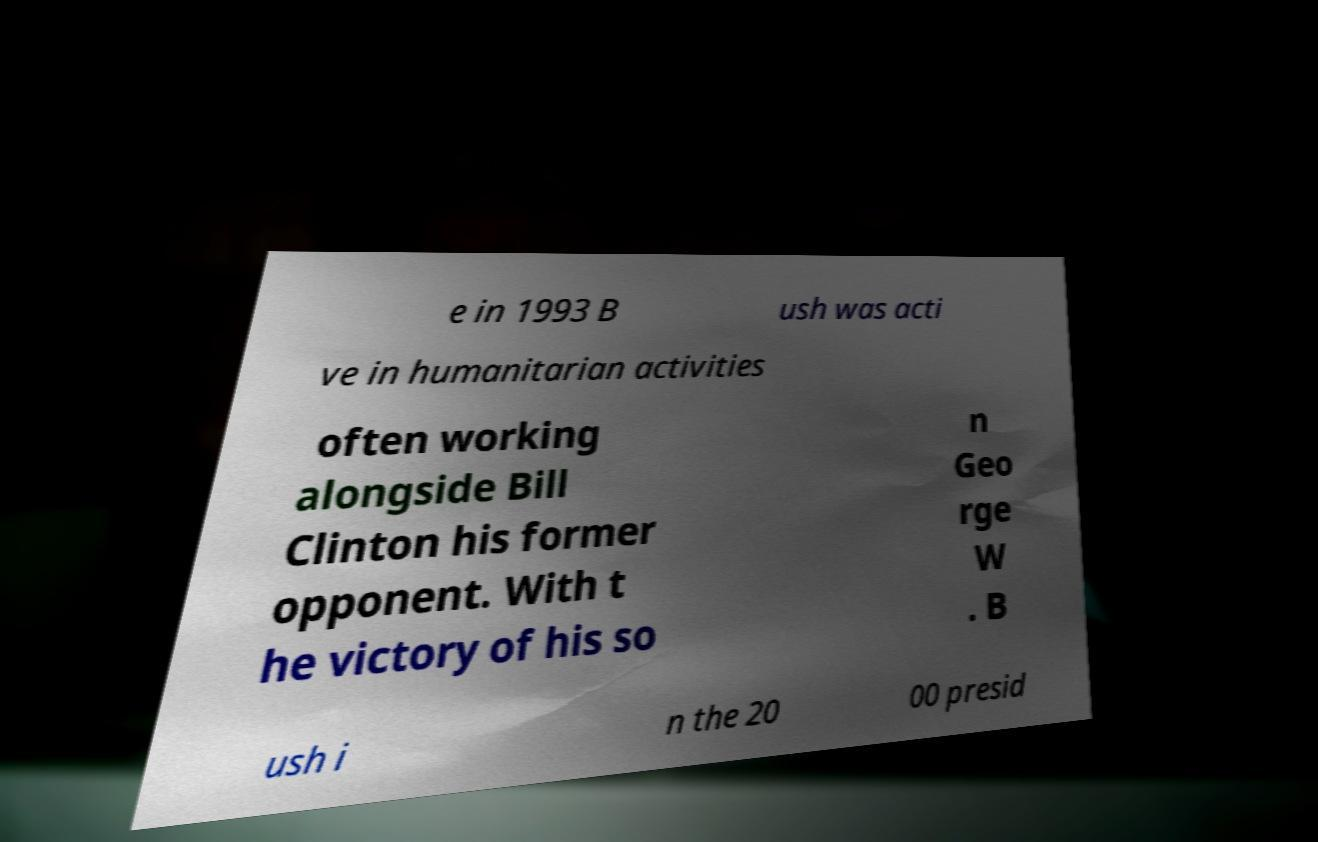Please identify and transcribe the text found in this image. e in 1993 B ush was acti ve in humanitarian activities often working alongside Bill Clinton his former opponent. With t he victory of his so n Geo rge W . B ush i n the 20 00 presid 